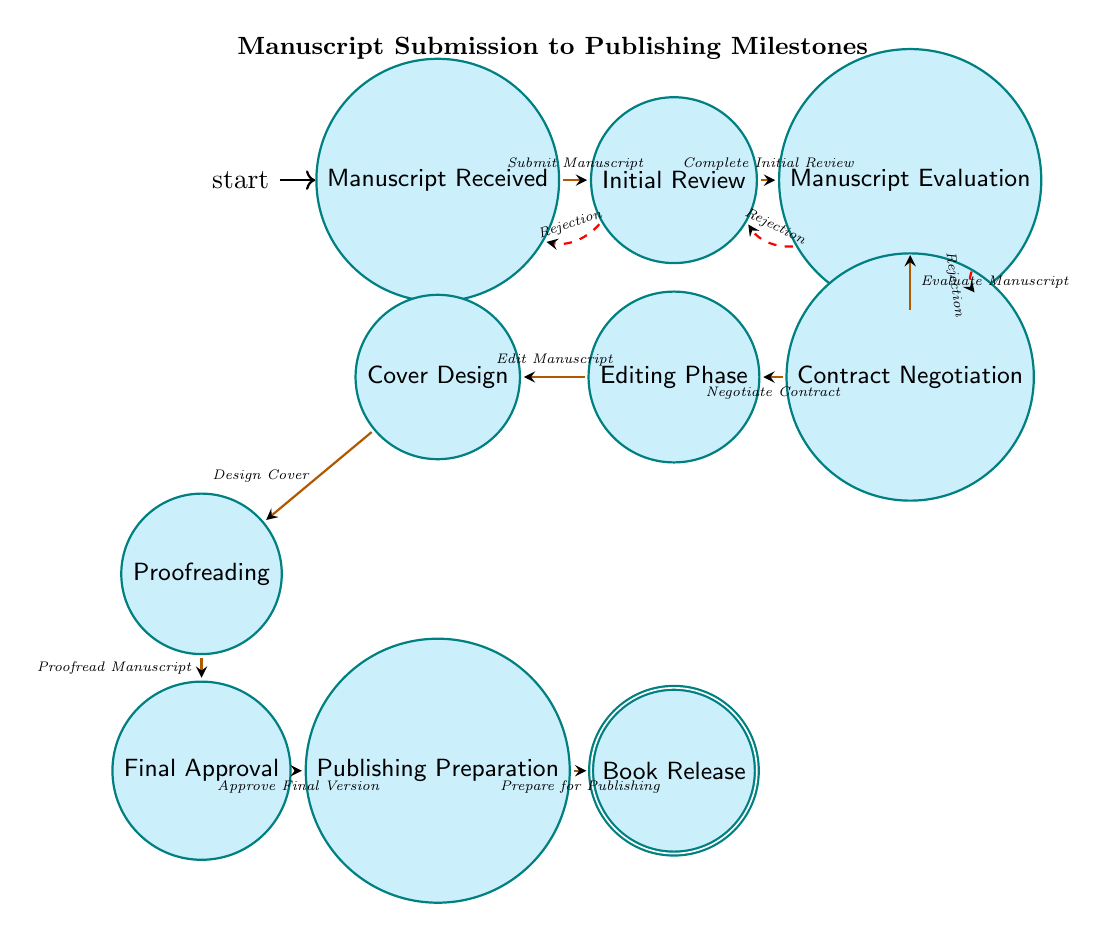What's the total number of states in the diagram? The diagram lists ten unique states that represent different milestones in the manuscript submission process. By counting them directly, we find that there are ten states present.
Answer: 10 What are the states directly following "Initial Review"? From the diagram, "Initial Review" connects to two states: "Manuscript Evaluation" and has a rejection loop back to "Manuscript Received". The states directly following "Initial Review" are "Manuscript Evaluation" and "Rejection".
Answer: Manuscript Evaluation, Rejection What is the final state in the transition sequence? The transition sequence leads to a single terminal state after various processes. By following the directed transitions from the initial state through to the end point, the last state reached is "Book Release".
Answer: Book Release How many transitions lead to a rejection? The diagram depicts three distinct transitions that lead to "Rejection". They are: "Initial Review" to "Manuscript Received", "Manuscript Evaluation" to "Initial Review", and "Contract Negotiation" to "Manuscript Evaluation".
Answer: 3 What is the next state after "Final Approval"? The last transition in the sequence after "Final Approval" points to "Publishing Preparation". Following the directed diagram, the immediate next state is confirmed as "Publishing Preparation".
Answer: Publishing Preparation If a manuscript is rejected during "Contract Negotiation", which state does it revert to? Since the transition from "Contract Negotiation" to "Rejection" indicates a failure in that stage, the arrow shows that it transitions back to "Manuscript Evaluation". Thus, if rejected at this point, the process reverts to "Manuscript Evaluation".
Answer: Manuscript Evaluation What state is reached after "Editing Phase"? Following the directed transition from "Editing Phase", the next state along the flow of the diagram is "Cover Design". Each state is linked sequentially, leading directly from one to the next.
Answer: Cover Design 